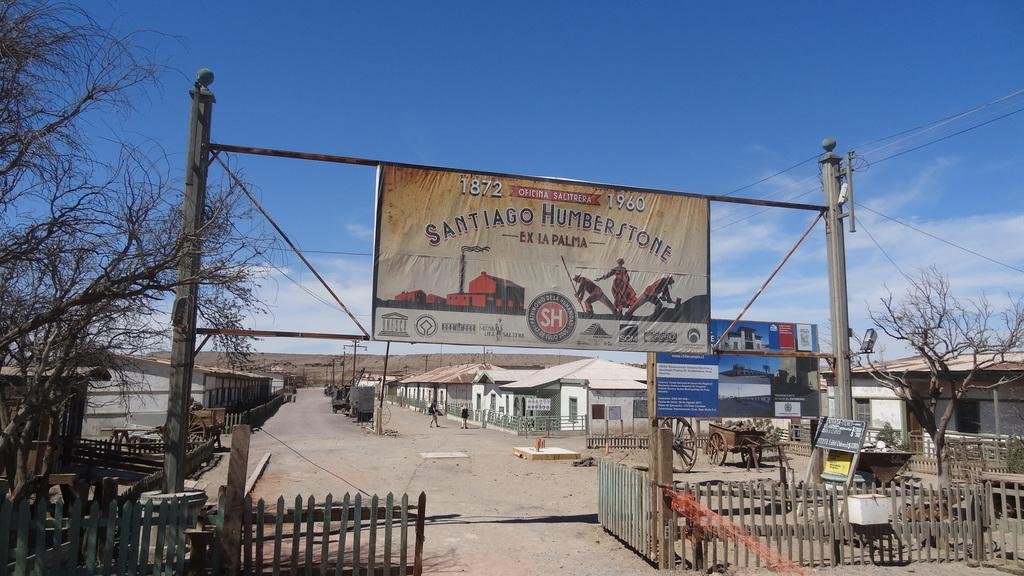<image>
Relay a brief, clear account of the picture shown. A sign over an open gate reads Santiago Humberstone. 